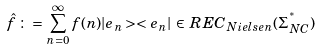<formula> <loc_0><loc_0><loc_500><loc_500>\hat { f } \, \colon = \, \sum _ { n = 0 } ^ { \infty } f ( n ) | e _ { n } > < e _ { n } | \, \in \, R E C _ { N i e l s e n } ( \Sigma _ { N C } ^ { ^ { * } } )</formula> 